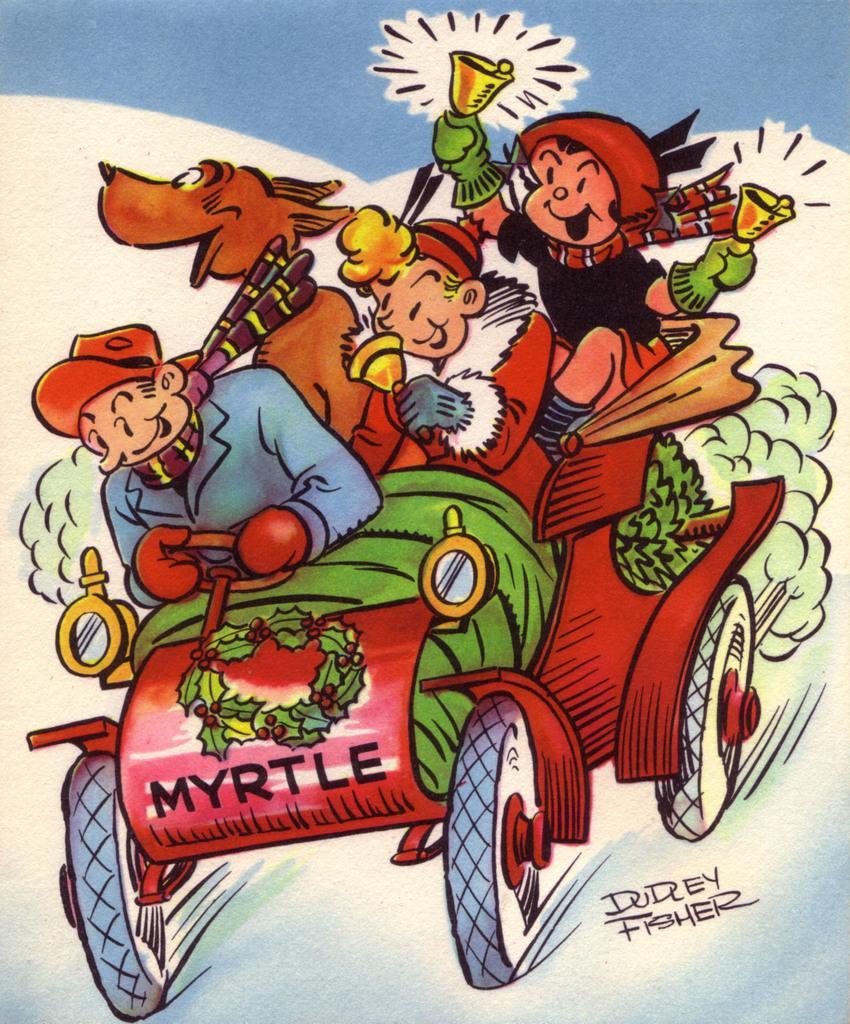How would you summarize this image in a sentence or two? In the image we can see there is a cartoon picture in which there is a car and people are sitting in it. They are holding bells in their hand and there is a dog sitting along with them. 